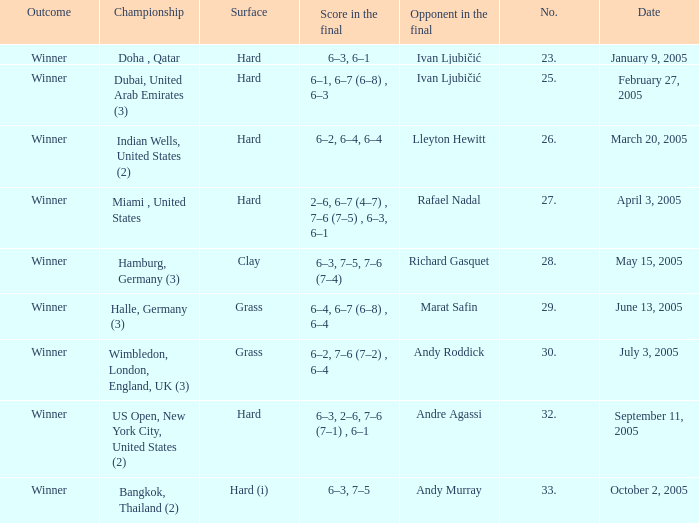Marat Safin is the opponent in the final in what championship? Halle, Germany (3). 